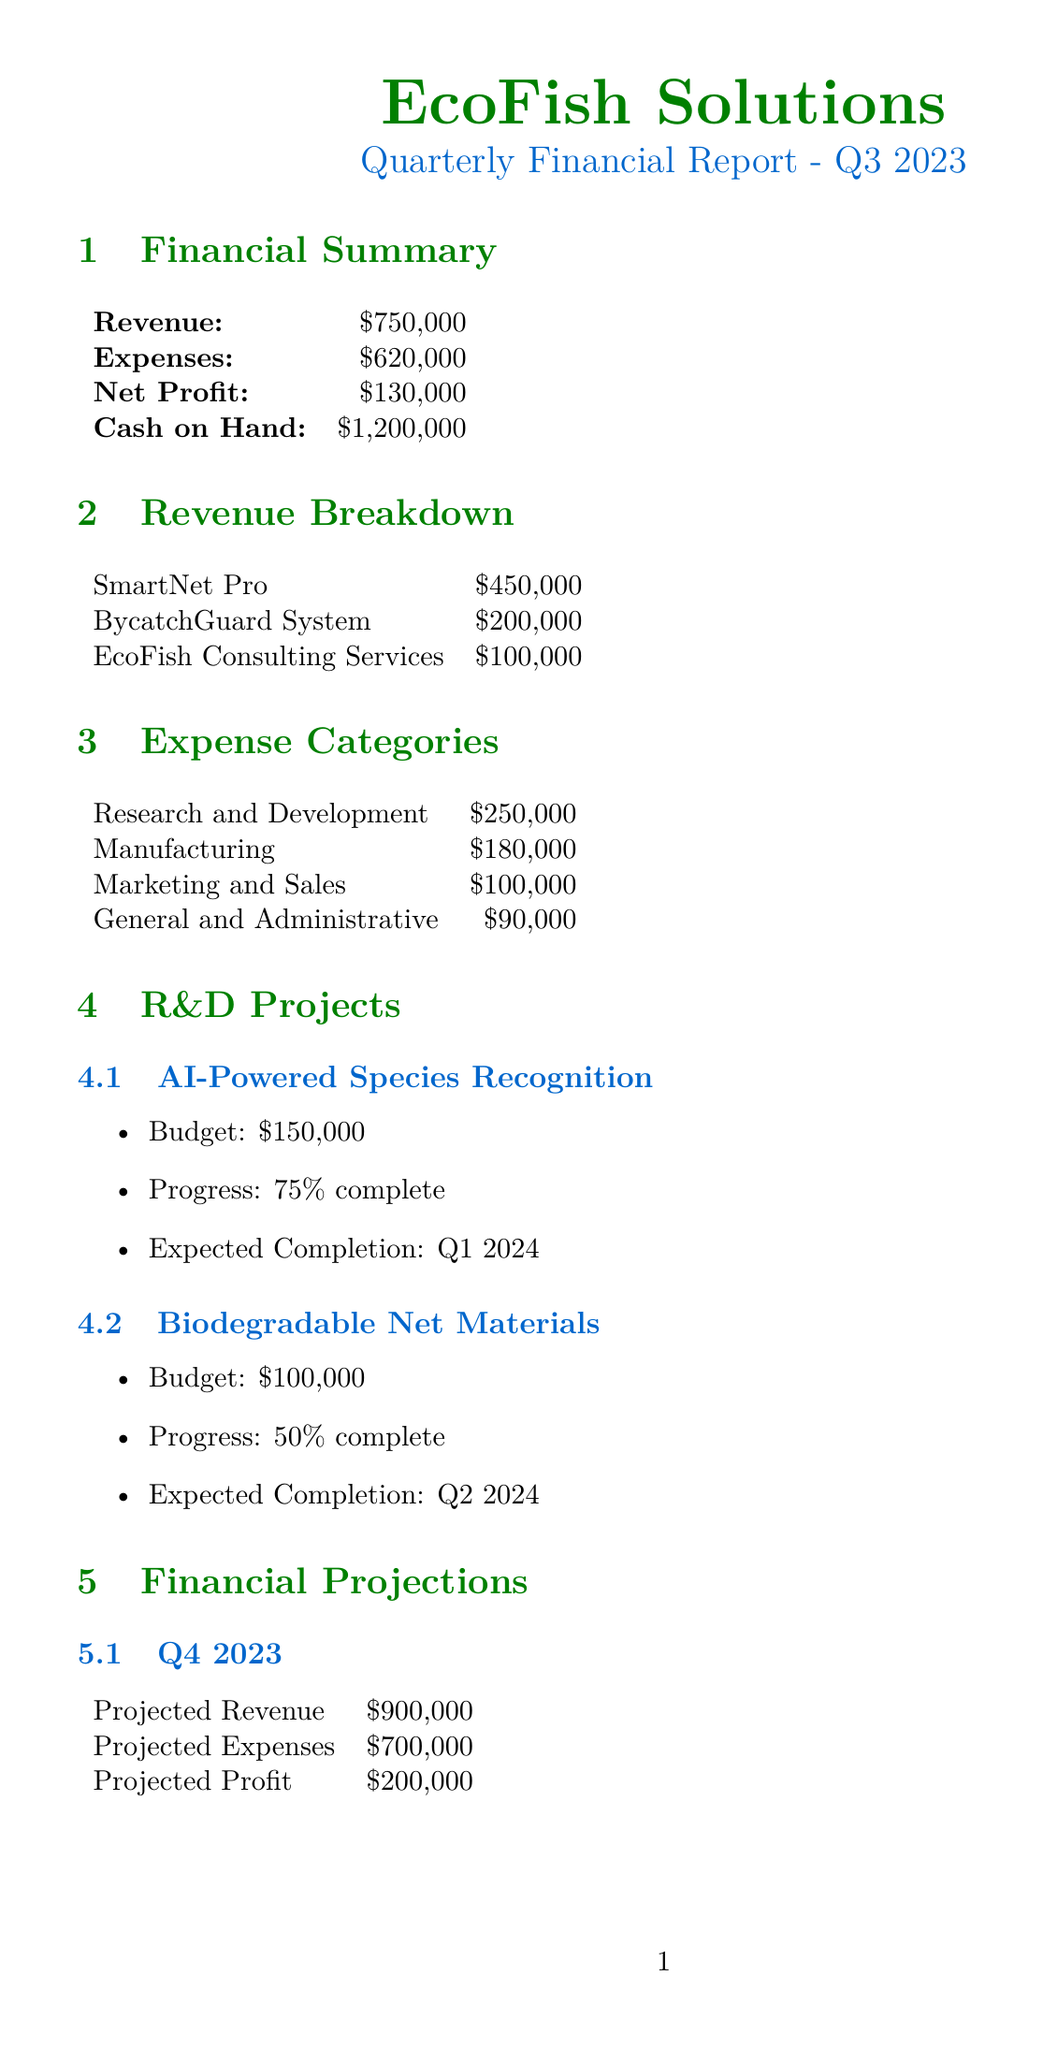what is the net profit for Q3 2023? The net profit is calculated as revenue minus expenses, which is $750,000 - $620,000.
Answer: $130,000 what is the total amount allocated to Research and Development? The total amount allocated to Research and Development is specified in the expense categories section of the document.
Answer: $250,000 what is the projected profit for FY 2024? The projected profit for FY 2024 is listed in the financial projections section.
Answer: $800,000 how many projects are currently in R&D? The R&D projects section lists two specific projects currently underway.
Answer: 2 what is the equity offered in the Series B Funding Round? The equity offered in the Series B Funding Round is mentioned under investor opportunities.
Answer: 10% what is the budget for the AI-Powered Species Recognition project? The budget for this R&D project is detailed in the R&D projects section of the document.
Answer: $150,000 what is the expected completion date for Biodegradable Net Materials project? The expected completion date is stated in the R&D projects section.
Answer: Q2 2024 what is EcoFish Solutions' current market share? The current market share is detailed in the market analysis section of the report.
Answer: 2.5% what is the target amount for the Series B Funding Round? The target amount is specified in the investor opportunities section of the document.
Answer: $5,000,000 